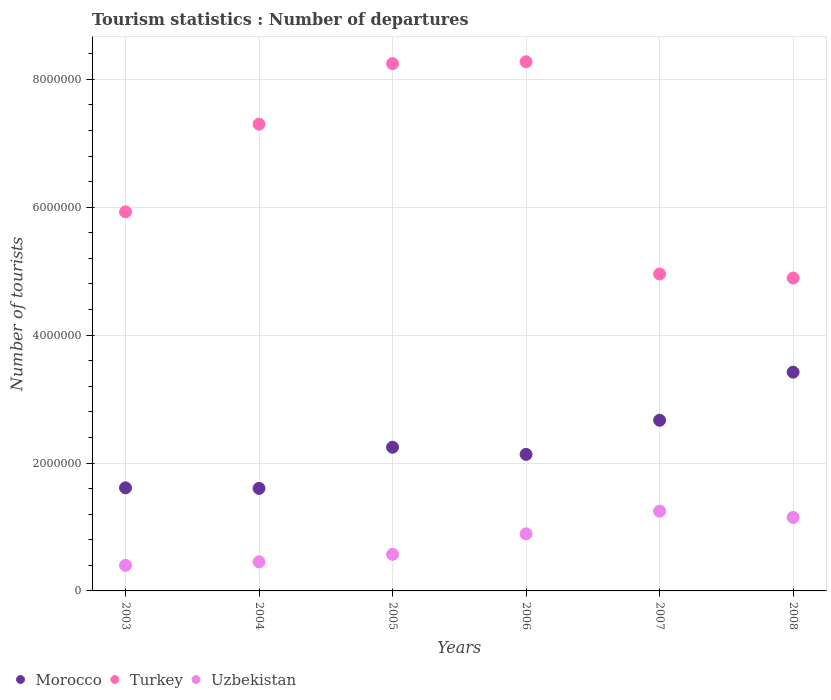How many different coloured dotlines are there?
Your response must be concise. 3. Is the number of dotlines equal to the number of legend labels?
Ensure brevity in your answer.  Yes. What is the number of tourist departures in Morocco in 2004?
Offer a terse response. 1.60e+06. Across all years, what is the maximum number of tourist departures in Uzbekistan?
Your response must be concise. 1.25e+06. What is the total number of tourist departures in Turkey in the graph?
Give a very brief answer. 3.96e+07. What is the difference between the number of tourist departures in Turkey in 2006 and that in 2007?
Ensure brevity in your answer.  3.32e+06. What is the difference between the number of tourist departures in Uzbekistan in 2003 and the number of tourist departures in Turkey in 2007?
Your response must be concise. -4.56e+06. What is the average number of tourist departures in Turkey per year?
Provide a short and direct response. 6.60e+06. In the year 2003, what is the difference between the number of tourist departures in Uzbekistan and number of tourist departures in Morocco?
Give a very brief answer. -1.21e+06. What is the ratio of the number of tourist departures in Morocco in 2006 to that in 2008?
Offer a terse response. 0.62. What is the difference between the highest and the second highest number of tourist departures in Turkey?
Offer a very short reply. 2.90e+04. What is the difference between the highest and the lowest number of tourist departures in Morocco?
Your answer should be compact. 1.82e+06. Is it the case that in every year, the sum of the number of tourist departures in Turkey and number of tourist departures in Uzbekistan  is greater than the number of tourist departures in Morocco?
Your answer should be very brief. Yes. Does the number of tourist departures in Turkey monotonically increase over the years?
Provide a succinct answer. No. Is the number of tourist departures in Morocco strictly less than the number of tourist departures in Turkey over the years?
Your response must be concise. Yes. How many dotlines are there?
Your response must be concise. 3. What is the difference between two consecutive major ticks on the Y-axis?
Provide a succinct answer. 2.00e+06. How are the legend labels stacked?
Offer a terse response. Horizontal. What is the title of the graph?
Provide a short and direct response. Tourism statistics : Number of departures. What is the label or title of the X-axis?
Provide a succinct answer. Years. What is the label or title of the Y-axis?
Ensure brevity in your answer.  Number of tourists. What is the Number of tourists of Morocco in 2003?
Keep it short and to the point. 1.61e+06. What is the Number of tourists of Turkey in 2003?
Your response must be concise. 5.93e+06. What is the Number of tourists in Uzbekistan in 2003?
Your answer should be compact. 4.00e+05. What is the Number of tourists in Morocco in 2004?
Keep it short and to the point. 1.60e+06. What is the Number of tourists of Turkey in 2004?
Your answer should be very brief. 7.30e+06. What is the Number of tourists of Uzbekistan in 2004?
Provide a short and direct response. 4.55e+05. What is the Number of tourists in Morocco in 2005?
Make the answer very short. 2.25e+06. What is the Number of tourists in Turkey in 2005?
Offer a very short reply. 8.25e+06. What is the Number of tourists of Uzbekistan in 2005?
Provide a short and direct response. 5.72e+05. What is the Number of tourists of Morocco in 2006?
Make the answer very short. 2.14e+06. What is the Number of tourists in Turkey in 2006?
Ensure brevity in your answer.  8.28e+06. What is the Number of tourists of Uzbekistan in 2006?
Give a very brief answer. 8.93e+05. What is the Number of tourists of Morocco in 2007?
Your answer should be very brief. 2.67e+06. What is the Number of tourists in Turkey in 2007?
Keep it short and to the point. 4.96e+06. What is the Number of tourists in Uzbekistan in 2007?
Your response must be concise. 1.25e+06. What is the Number of tourists in Morocco in 2008?
Your answer should be compact. 3.42e+06. What is the Number of tourists in Turkey in 2008?
Offer a terse response. 4.89e+06. What is the Number of tourists in Uzbekistan in 2008?
Keep it short and to the point. 1.15e+06. Across all years, what is the maximum Number of tourists of Morocco?
Provide a succinct answer. 3.42e+06. Across all years, what is the maximum Number of tourists of Turkey?
Provide a short and direct response. 8.28e+06. Across all years, what is the maximum Number of tourists of Uzbekistan?
Give a very brief answer. 1.25e+06. Across all years, what is the minimum Number of tourists of Morocco?
Your answer should be very brief. 1.60e+06. Across all years, what is the minimum Number of tourists of Turkey?
Provide a succinct answer. 4.89e+06. Across all years, what is the minimum Number of tourists of Uzbekistan?
Offer a very short reply. 4.00e+05. What is the total Number of tourists of Morocco in the graph?
Offer a very short reply. 1.37e+07. What is the total Number of tourists of Turkey in the graph?
Give a very brief answer. 3.96e+07. What is the total Number of tourists of Uzbekistan in the graph?
Your answer should be compact. 4.72e+06. What is the difference between the Number of tourists of Morocco in 2003 and that in 2004?
Provide a short and direct response. 9000. What is the difference between the Number of tourists in Turkey in 2003 and that in 2004?
Ensure brevity in your answer.  -1.37e+06. What is the difference between the Number of tourists of Uzbekistan in 2003 and that in 2004?
Your response must be concise. -5.50e+04. What is the difference between the Number of tourists in Morocco in 2003 and that in 2005?
Your response must be concise. -6.35e+05. What is the difference between the Number of tourists in Turkey in 2003 and that in 2005?
Make the answer very short. -2.32e+06. What is the difference between the Number of tourists in Uzbekistan in 2003 and that in 2005?
Make the answer very short. -1.72e+05. What is the difference between the Number of tourists in Morocco in 2003 and that in 2006?
Provide a short and direct response. -5.23e+05. What is the difference between the Number of tourists of Turkey in 2003 and that in 2006?
Your response must be concise. -2.35e+06. What is the difference between the Number of tourists of Uzbekistan in 2003 and that in 2006?
Your answer should be very brief. -4.93e+05. What is the difference between the Number of tourists in Morocco in 2003 and that in 2007?
Your response must be concise. -1.06e+06. What is the difference between the Number of tourists of Turkey in 2003 and that in 2007?
Ensure brevity in your answer.  9.72e+05. What is the difference between the Number of tourists in Uzbekistan in 2003 and that in 2007?
Provide a short and direct response. -8.48e+05. What is the difference between the Number of tourists in Morocco in 2003 and that in 2008?
Offer a very short reply. -1.81e+06. What is the difference between the Number of tourists of Turkey in 2003 and that in 2008?
Ensure brevity in your answer.  1.04e+06. What is the difference between the Number of tourists in Uzbekistan in 2003 and that in 2008?
Keep it short and to the point. -7.50e+05. What is the difference between the Number of tourists of Morocco in 2004 and that in 2005?
Ensure brevity in your answer.  -6.44e+05. What is the difference between the Number of tourists of Turkey in 2004 and that in 2005?
Make the answer very short. -9.47e+05. What is the difference between the Number of tourists in Uzbekistan in 2004 and that in 2005?
Ensure brevity in your answer.  -1.17e+05. What is the difference between the Number of tourists in Morocco in 2004 and that in 2006?
Ensure brevity in your answer.  -5.32e+05. What is the difference between the Number of tourists of Turkey in 2004 and that in 2006?
Ensure brevity in your answer.  -9.76e+05. What is the difference between the Number of tourists in Uzbekistan in 2004 and that in 2006?
Give a very brief answer. -4.38e+05. What is the difference between the Number of tourists of Morocco in 2004 and that in 2007?
Your answer should be very brief. -1.07e+06. What is the difference between the Number of tourists in Turkey in 2004 and that in 2007?
Keep it short and to the point. 2.34e+06. What is the difference between the Number of tourists in Uzbekistan in 2004 and that in 2007?
Give a very brief answer. -7.93e+05. What is the difference between the Number of tourists of Morocco in 2004 and that in 2008?
Offer a very short reply. -1.82e+06. What is the difference between the Number of tourists in Turkey in 2004 and that in 2008?
Your response must be concise. 2.41e+06. What is the difference between the Number of tourists of Uzbekistan in 2004 and that in 2008?
Offer a very short reply. -6.95e+05. What is the difference between the Number of tourists of Morocco in 2005 and that in 2006?
Make the answer very short. 1.12e+05. What is the difference between the Number of tourists of Turkey in 2005 and that in 2006?
Provide a succinct answer. -2.90e+04. What is the difference between the Number of tourists of Uzbekistan in 2005 and that in 2006?
Provide a succinct answer. -3.21e+05. What is the difference between the Number of tourists in Morocco in 2005 and that in 2007?
Ensure brevity in your answer.  -4.22e+05. What is the difference between the Number of tourists of Turkey in 2005 and that in 2007?
Provide a succinct answer. 3.29e+06. What is the difference between the Number of tourists in Uzbekistan in 2005 and that in 2007?
Offer a very short reply. -6.76e+05. What is the difference between the Number of tourists in Morocco in 2005 and that in 2008?
Provide a short and direct response. -1.17e+06. What is the difference between the Number of tourists in Turkey in 2005 and that in 2008?
Offer a very short reply. 3.35e+06. What is the difference between the Number of tourists in Uzbekistan in 2005 and that in 2008?
Your answer should be very brief. -5.78e+05. What is the difference between the Number of tourists of Morocco in 2006 and that in 2007?
Provide a succinct answer. -5.34e+05. What is the difference between the Number of tourists of Turkey in 2006 and that in 2007?
Give a very brief answer. 3.32e+06. What is the difference between the Number of tourists of Uzbekistan in 2006 and that in 2007?
Offer a terse response. -3.55e+05. What is the difference between the Number of tourists of Morocco in 2006 and that in 2008?
Keep it short and to the point. -1.29e+06. What is the difference between the Number of tourists of Turkey in 2006 and that in 2008?
Your answer should be very brief. 3.38e+06. What is the difference between the Number of tourists of Uzbekistan in 2006 and that in 2008?
Give a very brief answer. -2.57e+05. What is the difference between the Number of tourists of Morocco in 2007 and that in 2008?
Offer a terse response. -7.52e+05. What is the difference between the Number of tourists of Turkey in 2007 and that in 2008?
Offer a terse response. 6.30e+04. What is the difference between the Number of tourists of Uzbekistan in 2007 and that in 2008?
Provide a short and direct response. 9.80e+04. What is the difference between the Number of tourists in Morocco in 2003 and the Number of tourists in Turkey in 2004?
Your response must be concise. -5.69e+06. What is the difference between the Number of tourists in Morocco in 2003 and the Number of tourists in Uzbekistan in 2004?
Offer a terse response. 1.16e+06. What is the difference between the Number of tourists of Turkey in 2003 and the Number of tourists of Uzbekistan in 2004?
Give a very brief answer. 5.47e+06. What is the difference between the Number of tourists in Morocco in 2003 and the Number of tourists in Turkey in 2005?
Give a very brief answer. -6.63e+06. What is the difference between the Number of tourists in Morocco in 2003 and the Number of tourists in Uzbekistan in 2005?
Offer a very short reply. 1.04e+06. What is the difference between the Number of tourists in Turkey in 2003 and the Number of tourists in Uzbekistan in 2005?
Provide a short and direct response. 5.36e+06. What is the difference between the Number of tourists of Morocco in 2003 and the Number of tourists of Turkey in 2006?
Give a very brief answer. -6.66e+06. What is the difference between the Number of tourists of Morocco in 2003 and the Number of tourists of Uzbekistan in 2006?
Give a very brief answer. 7.19e+05. What is the difference between the Number of tourists in Turkey in 2003 and the Number of tourists in Uzbekistan in 2006?
Give a very brief answer. 5.04e+06. What is the difference between the Number of tourists in Morocco in 2003 and the Number of tourists in Turkey in 2007?
Provide a short and direct response. -3.34e+06. What is the difference between the Number of tourists of Morocco in 2003 and the Number of tourists of Uzbekistan in 2007?
Provide a short and direct response. 3.64e+05. What is the difference between the Number of tourists of Turkey in 2003 and the Number of tourists of Uzbekistan in 2007?
Offer a terse response. 4.68e+06. What is the difference between the Number of tourists in Morocco in 2003 and the Number of tourists in Turkey in 2008?
Your answer should be very brief. -3.28e+06. What is the difference between the Number of tourists of Morocco in 2003 and the Number of tourists of Uzbekistan in 2008?
Provide a succinct answer. 4.62e+05. What is the difference between the Number of tourists of Turkey in 2003 and the Number of tourists of Uzbekistan in 2008?
Offer a terse response. 4.78e+06. What is the difference between the Number of tourists in Morocco in 2004 and the Number of tourists in Turkey in 2005?
Make the answer very short. -6.64e+06. What is the difference between the Number of tourists in Morocco in 2004 and the Number of tourists in Uzbekistan in 2005?
Give a very brief answer. 1.03e+06. What is the difference between the Number of tourists in Turkey in 2004 and the Number of tourists in Uzbekistan in 2005?
Offer a terse response. 6.73e+06. What is the difference between the Number of tourists in Morocco in 2004 and the Number of tourists in Turkey in 2006?
Offer a very short reply. -6.67e+06. What is the difference between the Number of tourists in Morocco in 2004 and the Number of tourists in Uzbekistan in 2006?
Your response must be concise. 7.10e+05. What is the difference between the Number of tourists in Turkey in 2004 and the Number of tourists in Uzbekistan in 2006?
Provide a succinct answer. 6.41e+06. What is the difference between the Number of tourists in Morocco in 2004 and the Number of tourists in Turkey in 2007?
Your response must be concise. -3.35e+06. What is the difference between the Number of tourists of Morocco in 2004 and the Number of tourists of Uzbekistan in 2007?
Offer a terse response. 3.55e+05. What is the difference between the Number of tourists in Turkey in 2004 and the Number of tourists in Uzbekistan in 2007?
Offer a very short reply. 6.05e+06. What is the difference between the Number of tourists of Morocco in 2004 and the Number of tourists of Turkey in 2008?
Provide a succinct answer. -3.29e+06. What is the difference between the Number of tourists of Morocco in 2004 and the Number of tourists of Uzbekistan in 2008?
Your response must be concise. 4.53e+05. What is the difference between the Number of tourists in Turkey in 2004 and the Number of tourists in Uzbekistan in 2008?
Make the answer very short. 6.15e+06. What is the difference between the Number of tourists of Morocco in 2005 and the Number of tourists of Turkey in 2006?
Keep it short and to the point. -6.03e+06. What is the difference between the Number of tourists in Morocco in 2005 and the Number of tourists in Uzbekistan in 2006?
Ensure brevity in your answer.  1.35e+06. What is the difference between the Number of tourists in Turkey in 2005 and the Number of tourists in Uzbekistan in 2006?
Your answer should be compact. 7.35e+06. What is the difference between the Number of tourists in Morocco in 2005 and the Number of tourists in Turkey in 2007?
Provide a succinct answer. -2.71e+06. What is the difference between the Number of tourists in Morocco in 2005 and the Number of tourists in Uzbekistan in 2007?
Keep it short and to the point. 9.99e+05. What is the difference between the Number of tourists in Turkey in 2005 and the Number of tourists in Uzbekistan in 2007?
Provide a succinct answer. 7.00e+06. What is the difference between the Number of tourists in Morocco in 2005 and the Number of tourists in Turkey in 2008?
Offer a very short reply. -2.65e+06. What is the difference between the Number of tourists in Morocco in 2005 and the Number of tourists in Uzbekistan in 2008?
Keep it short and to the point. 1.10e+06. What is the difference between the Number of tourists in Turkey in 2005 and the Number of tourists in Uzbekistan in 2008?
Provide a short and direct response. 7.10e+06. What is the difference between the Number of tourists of Morocco in 2006 and the Number of tourists of Turkey in 2007?
Provide a succinct answer. -2.82e+06. What is the difference between the Number of tourists of Morocco in 2006 and the Number of tourists of Uzbekistan in 2007?
Your answer should be very brief. 8.87e+05. What is the difference between the Number of tourists of Turkey in 2006 and the Number of tourists of Uzbekistan in 2007?
Offer a very short reply. 7.03e+06. What is the difference between the Number of tourists in Morocco in 2006 and the Number of tourists in Turkey in 2008?
Give a very brief answer. -2.76e+06. What is the difference between the Number of tourists in Morocco in 2006 and the Number of tourists in Uzbekistan in 2008?
Provide a succinct answer. 9.85e+05. What is the difference between the Number of tourists of Turkey in 2006 and the Number of tourists of Uzbekistan in 2008?
Keep it short and to the point. 7.12e+06. What is the difference between the Number of tourists in Morocco in 2007 and the Number of tourists in Turkey in 2008?
Provide a short and direct response. -2.22e+06. What is the difference between the Number of tourists of Morocco in 2007 and the Number of tourists of Uzbekistan in 2008?
Offer a terse response. 1.52e+06. What is the difference between the Number of tourists of Turkey in 2007 and the Number of tourists of Uzbekistan in 2008?
Offer a very short reply. 3.81e+06. What is the average Number of tourists of Morocco per year?
Provide a succinct answer. 2.28e+06. What is the average Number of tourists of Turkey per year?
Keep it short and to the point. 6.60e+06. What is the average Number of tourists in Uzbekistan per year?
Your answer should be very brief. 7.86e+05. In the year 2003, what is the difference between the Number of tourists of Morocco and Number of tourists of Turkey?
Make the answer very short. -4.32e+06. In the year 2003, what is the difference between the Number of tourists of Morocco and Number of tourists of Uzbekistan?
Provide a short and direct response. 1.21e+06. In the year 2003, what is the difference between the Number of tourists of Turkey and Number of tourists of Uzbekistan?
Provide a succinct answer. 5.53e+06. In the year 2004, what is the difference between the Number of tourists of Morocco and Number of tourists of Turkey?
Provide a short and direct response. -5.70e+06. In the year 2004, what is the difference between the Number of tourists of Morocco and Number of tourists of Uzbekistan?
Your response must be concise. 1.15e+06. In the year 2004, what is the difference between the Number of tourists in Turkey and Number of tourists in Uzbekistan?
Provide a short and direct response. 6.84e+06. In the year 2005, what is the difference between the Number of tourists in Morocco and Number of tourists in Turkey?
Your answer should be very brief. -6.00e+06. In the year 2005, what is the difference between the Number of tourists in Morocco and Number of tourists in Uzbekistan?
Your response must be concise. 1.68e+06. In the year 2005, what is the difference between the Number of tourists in Turkey and Number of tourists in Uzbekistan?
Offer a terse response. 7.67e+06. In the year 2006, what is the difference between the Number of tourists in Morocco and Number of tourists in Turkey?
Your answer should be very brief. -6.14e+06. In the year 2006, what is the difference between the Number of tourists of Morocco and Number of tourists of Uzbekistan?
Make the answer very short. 1.24e+06. In the year 2006, what is the difference between the Number of tourists of Turkey and Number of tourists of Uzbekistan?
Provide a succinct answer. 7.38e+06. In the year 2007, what is the difference between the Number of tourists in Morocco and Number of tourists in Turkey?
Your answer should be compact. -2.29e+06. In the year 2007, what is the difference between the Number of tourists of Morocco and Number of tourists of Uzbekistan?
Ensure brevity in your answer.  1.42e+06. In the year 2007, what is the difference between the Number of tourists of Turkey and Number of tourists of Uzbekistan?
Give a very brief answer. 3.71e+06. In the year 2008, what is the difference between the Number of tourists in Morocco and Number of tourists in Turkey?
Your answer should be compact. -1.47e+06. In the year 2008, what is the difference between the Number of tourists in Morocco and Number of tourists in Uzbekistan?
Provide a short and direct response. 2.27e+06. In the year 2008, what is the difference between the Number of tourists of Turkey and Number of tourists of Uzbekistan?
Make the answer very short. 3.74e+06. What is the ratio of the Number of tourists in Morocco in 2003 to that in 2004?
Offer a terse response. 1.01. What is the ratio of the Number of tourists of Turkey in 2003 to that in 2004?
Make the answer very short. 0.81. What is the ratio of the Number of tourists of Uzbekistan in 2003 to that in 2004?
Ensure brevity in your answer.  0.88. What is the ratio of the Number of tourists in Morocco in 2003 to that in 2005?
Provide a short and direct response. 0.72. What is the ratio of the Number of tourists of Turkey in 2003 to that in 2005?
Provide a short and direct response. 0.72. What is the ratio of the Number of tourists of Uzbekistan in 2003 to that in 2005?
Provide a succinct answer. 0.7. What is the ratio of the Number of tourists in Morocco in 2003 to that in 2006?
Offer a very short reply. 0.76. What is the ratio of the Number of tourists of Turkey in 2003 to that in 2006?
Provide a short and direct response. 0.72. What is the ratio of the Number of tourists in Uzbekistan in 2003 to that in 2006?
Give a very brief answer. 0.45. What is the ratio of the Number of tourists in Morocco in 2003 to that in 2007?
Make the answer very short. 0.6. What is the ratio of the Number of tourists of Turkey in 2003 to that in 2007?
Ensure brevity in your answer.  1.2. What is the ratio of the Number of tourists of Uzbekistan in 2003 to that in 2007?
Your answer should be very brief. 0.32. What is the ratio of the Number of tourists in Morocco in 2003 to that in 2008?
Offer a terse response. 0.47. What is the ratio of the Number of tourists of Turkey in 2003 to that in 2008?
Make the answer very short. 1.21. What is the ratio of the Number of tourists in Uzbekistan in 2003 to that in 2008?
Provide a succinct answer. 0.35. What is the ratio of the Number of tourists in Morocco in 2004 to that in 2005?
Offer a terse response. 0.71. What is the ratio of the Number of tourists in Turkey in 2004 to that in 2005?
Offer a very short reply. 0.89. What is the ratio of the Number of tourists in Uzbekistan in 2004 to that in 2005?
Ensure brevity in your answer.  0.8. What is the ratio of the Number of tourists in Morocco in 2004 to that in 2006?
Offer a terse response. 0.75. What is the ratio of the Number of tourists of Turkey in 2004 to that in 2006?
Provide a succinct answer. 0.88. What is the ratio of the Number of tourists of Uzbekistan in 2004 to that in 2006?
Provide a succinct answer. 0.51. What is the ratio of the Number of tourists of Morocco in 2004 to that in 2007?
Make the answer very short. 0.6. What is the ratio of the Number of tourists in Turkey in 2004 to that in 2007?
Make the answer very short. 1.47. What is the ratio of the Number of tourists of Uzbekistan in 2004 to that in 2007?
Offer a terse response. 0.36. What is the ratio of the Number of tourists in Morocco in 2004 to that in 2008?
Your response must be concise. 0.47. What is the ratio of the Number of tourists of Turkey in 2004 to that in 2008?
Offer a very short reply. 1.49. What is the ratio of the Number of tourists in Uzbekistan in 2004 to that in 2008?
Offer a terse response. 0.4. What is the ratio of the Number of tourists of Morocco in 2005 to that in 2006?
Make the answer very short. 1.05. What is the ratio of the Number of tourists of Turkey in 2005 to that in 2006?
Offer a terse response. 1. What is the ratio of the Number of tourists of Uzbekistan in 2005 to that in 2006?
Offer a terse response. 0.64. What is the ratio of the Number of tourists of Morocco in 2005 to that in 2007?
Your response must be concise. 0.84. What is the ratio of the Number of tourists of Turkey in 2005 to that in 2007?
Keep it short and to the point. 1.66. What is the ratio of the Number of tourists in Uzbekistan in 2005 to that in 2007?
Offer a terse response. 0.46. What is the ratio of the Number of tourists in Morocco in 2005 to that in 2008?
Provide a succinct answer. 0.66. What is the ratio of the Number of tourists in Turkey in 2005 to that in 2008?
Your answer should be very brief. 1.69. What is the ratio of the Number of tourists in Uzbekistan in 2005 to that in 2008?
Your answer should be very brief. 0.5. What is the ratio of the Number of tourists of Morocco in 2006 to that in 2007?
Keep it short and to the point. 0.8. What is the ratio of the Number of tourists of Turkey in 2006 to that in 2007?
Make the answer very short. 1.67. What is the ratio of the Number of tourists of Uzbekistan in 2006 to that in 2007?
Offer a terse response. 0.72. What is the ratio of the Number of tourists in Morocco in 2006 to that in 2008?
Offer a terse response. 0.62. What is the ratio of the Number of tourists in Turkey in 2006 to that in 2008?
Offer a very short reply. 1.69. What is the ratio of the Number of tourists of Uzbekistan in 2006 to that in 2008?
Provide a succinct answer. 0.78. What is the ratio of the Number of tourists in Morocco in 2007 to that in 2008?
Make the answer very short. 0.78. What is the ratio of the Number of tourists of Turkey in 2007 to that in 2008?
Ensure brevity in your answer.  1.01. What is the ratio of the Number of tourists of Uzbekistan in 2007 to that in 2008?
Your answer should be compact. 1.09. What is the difference between the highest and the second highest Number of tourists in Morocco?
Give a very brief answer. 7.52e+05. What is the difference between the highest and the second highest Number of tourists of Turkey?
Keep it short and to the point. 2.90e+04. What is the difference between the highest and the second highest Number of tourists in Uzbekistan?
Ensure brevity in your answer.  9.80e+04. What is the difference between the highest and the lowest Number of tourists of Morocco?
Offer a terse response. 1.82e+06. What is the difference between the highest and the lowest Number of tourists in Turkey?
Make the answer very short. 3.38e+06. What is the difference between the highest and the lowest Number of tourists in Uzbekistan?
Ensure brevity in your answer.  8.48e+05. 